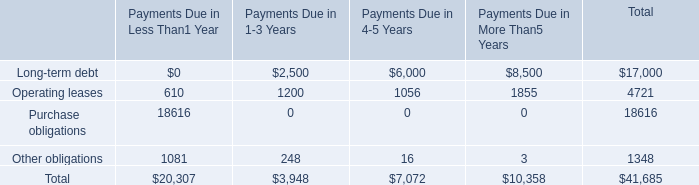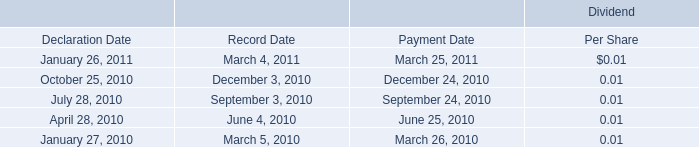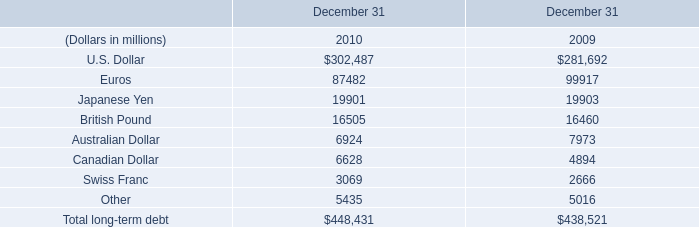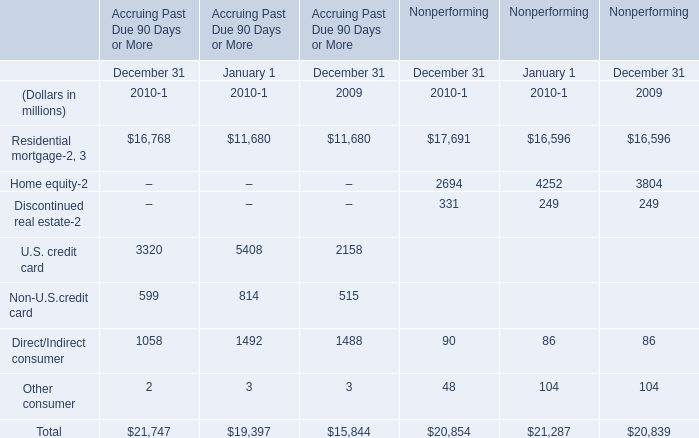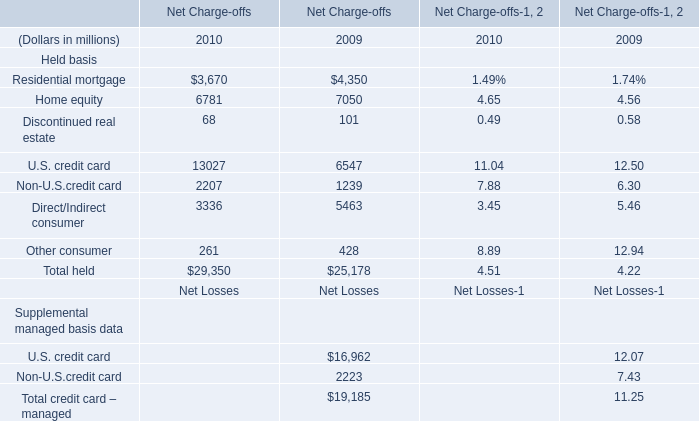What is the ratio of Residential mortgage in Nonperforming to the total in 2010? 
Computations: (17691 / 20854)
Answer: 0.84833. 